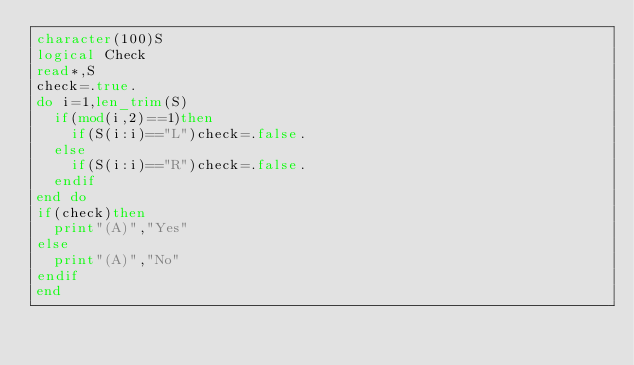Convert code to text. <code><loc_0><loc_0><loc_500><loc_500><_FORTRAN_>character(100)S
logical Check
read*,S
check=.true.
do i=1,len_trim(S)
  if(mod(i,2)==1)then
    if(S(i:i)=="L")check=.false.
  else
    if(S(i:i)=="R")check=.false.
  endif
end do
if(check)then
  print"(A)","Yes"
else
  print"(A)","No"
endif
end</code> 